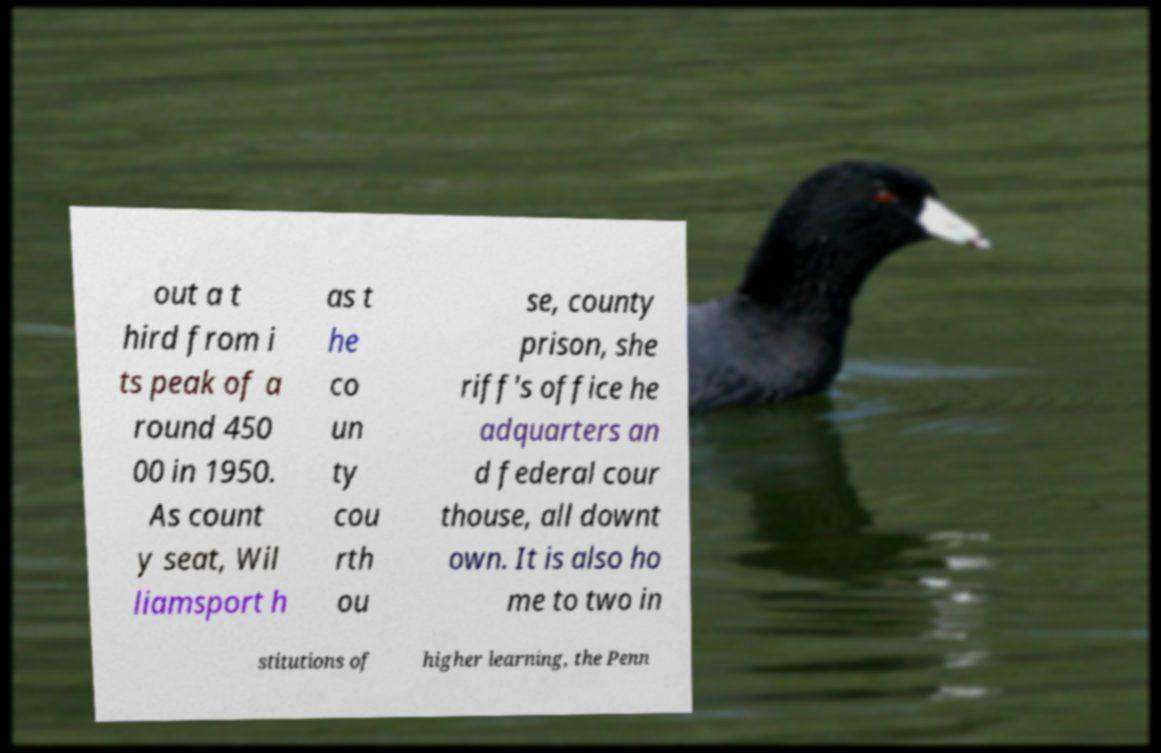Could you assist in decoding the text presented in this image and type it out clearly? out a t hird from i ts peak of a round 450 00 in 1950. As count y seat, Wil liamsport h as t he co un ty cou rth ou se, county prison, she riff's office he adquarters an d federal cour thouse, all downt own. It is also ho me to two in stitutions of higher learning, the Penn 